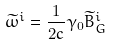<formula> <loc_0><loc_0><loc_500><loc_500>\widetilde { \omega } ^ { i } = \frac { 1 } { 2 c } \gamma _ { 0 } \widetilde { B } _ { G } ^ { i }</formula> 